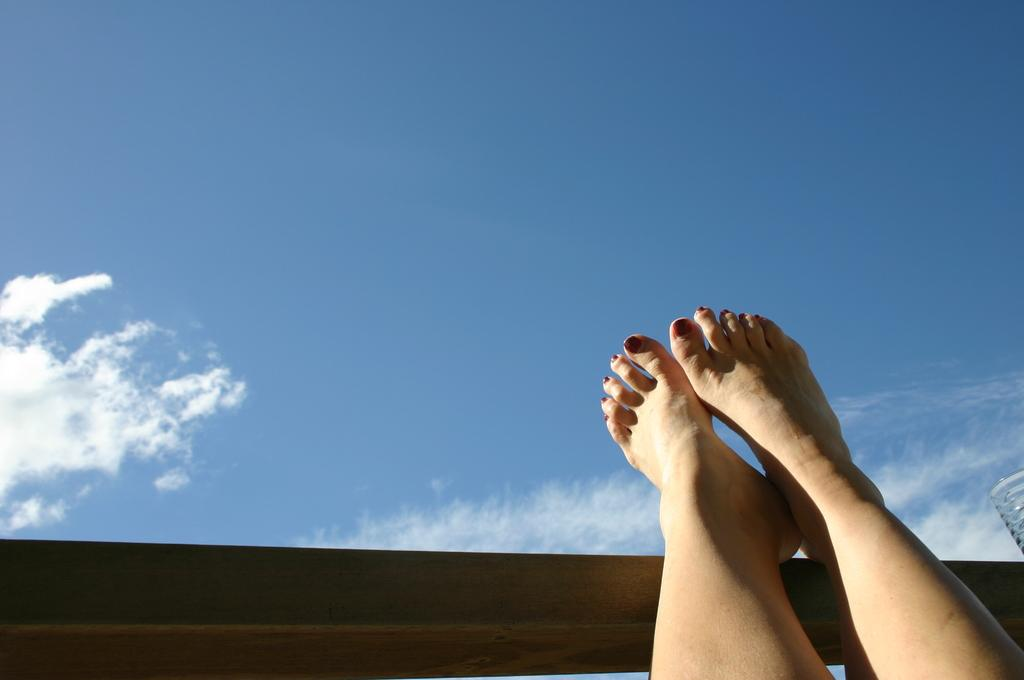What is the main subject of the image? There is a person in the image. What is the person's position in the image? The person's legs are hanging in the air. What is in front of the person? There appears to be a wall in front of the person. What can be seen above the person? The sky is visible above the person. What is the condition of the sky in the image? Clouds are present in the sky. What type of bread is being used as a shape in the image? There is no bread or shape present in the image. What joke is being told by the person in the image? There is no indication of a joke being told in the image. 